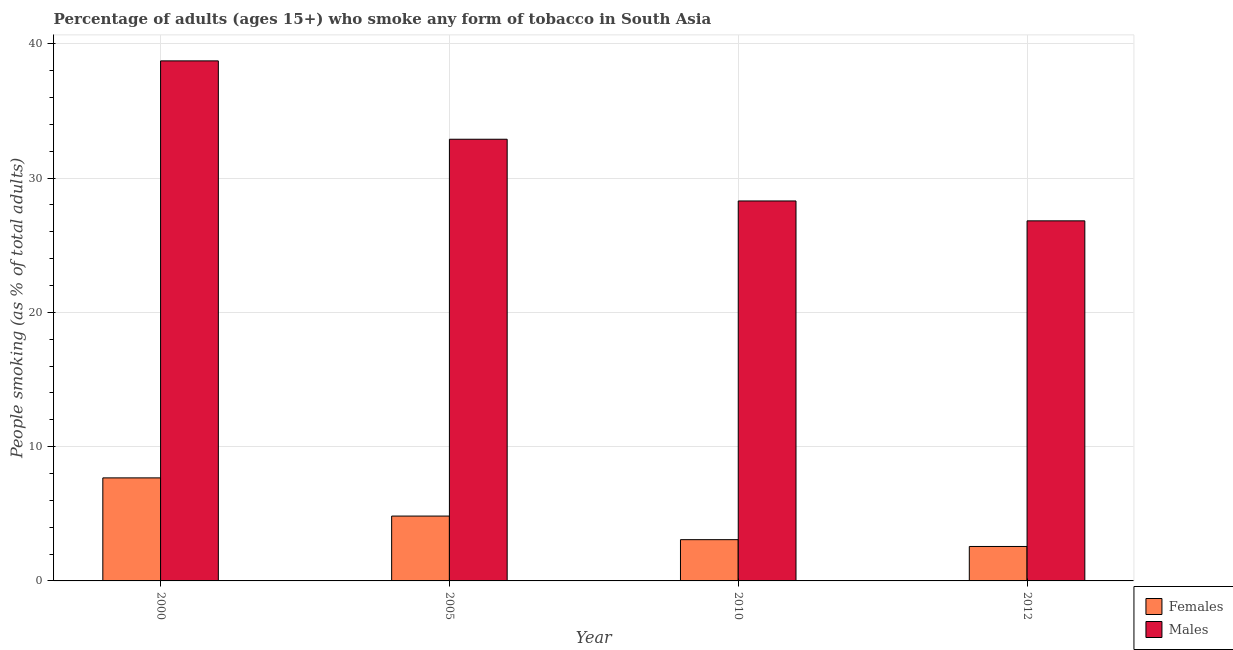How many different coloured bars are there?
Offer a terse response. 2. How many groups of bars are there?
Give a very brief answer. 4. Are the number of bars on each tick of the X-axis equal?
Offer a terse response. Yes. How many bars are there on the 1st tick from the left?
Provide a short and direct response. 2. In how many cases, is the number of bars for a given year not equal to the number of legend labels?
Keep it short and to the point. 0. What is the percentage of females who smoke in 2012?
Make the answer very short. 2.56. Across all years, what is the maximum percentage of females who smoke?
Offer a terse response. 7.67. Across all years, what is the minimum percentage of females who smoke?
Keep it short and to the point. 2.56. In which year was the percentage of females who smoke minimum?
Provide a succinct answer. 2012. What is the total percentage of males who smoke in the graph?
Your answer should be compact. 126.71. What is the difference between the percentage of females who smoke in 2010 and that in 2012?
Ensure brevity in your answer.  0.51. What is the difference between the percentage of males who smoke in 2005 and the percentage of females who smoke in 2010?
Make the answer very short. 4.6. What is the average percentage of males who smoke per year?
Provide a short and direct response. 31.68. What is the ratio of the percentage of females who smoke in 2010 to that in 2012?
Your answer should be very brief. 1.2. What is the difference between the highest and the second highest percentage of females who smoke?
Ensure brevity in your answer.  2.84. What is the difference between the highest and the lowest percentage of females who smoke?
Your answer should be very brief. 5.11. In how many years, is the percentage of males who smoke greater than the average percentage of males who smoke taken over all years?
Make the answer very short. 2. Is the sum of the percentage of females who smoke in 2000 and 2012 greater than the maximum percentage of males who smoke across all years?
Your response must be concise. Yes. What does the 2nd bar from the left in 2005 represents?
Offer a terse response. Males. What does the 2nd bar from the right in 2012 represents?
Give a very brief answer. Females. Are all the bars in the graph horizontal?
Offer a terse response. No. Are the values on the major ticks of Y-axis written in scientific E-notation?
Give a very brief answer. No. Does the graph contain any zero values?
Keep it short and to the point. No. How many legend labels are there?
Give a very brief answer. 2. What is the title of the graph?
Provide a short and direct response. Percentage of adults (ages 15+) who smoke any form of tobacco in South Asia. Does "Nitrous oxide" appear as one of the legend labels in the graph?
Provide a short and direct response. No. What is the label or title of the Y-axis?
Provide a succinct answer. People smoking (as % of total adults). What is the People smoking (as % of total adults) of Females in 2000?
Provide a succinct answer. 7.67. What is the People smoking (as % of total adults) in Males in 2000?
Your answer should be compact. 38.72. What is the People smoking (as % of total adults) of Females in 2005?
Keep it short and to the point. 4.83. What is the People smoking (as % of total adults) of Males in 2005?
Give a very brief answer. 32.89. What is the People smoking (as % of total adults) of Females in 2010?
Ensure brevity in your answer.  3.07. What is the People smoking (as % of total adults) of Males in 2010?
Give a very brief answer. 28.29. What is the People smoking (as % of total adults) of Females in 2012?
Provide a short and direct response. 2.56. What is the People smoking (as % of total adults) of Males in 2012?
Provide a short and direct response. 26.81. Across all years, what is the maximum People smoking (as % of total adults) in Females?
Your answer should be compact. 7.67. Across all years, what is the maximum People smoking (as % of total adults) in Males?
Your answer should be compact. 38.72. Across all years, what is the minimum People smoking (as % of total adults) in Females?
Give a very brief answer. 2.56. Across all years, what is the minimum People smoking (as % of total adults) in Males?
Give a very brief answer. 26.81. What is the total People smoking (as % of total adults) of Females in the graph?
Provide a short and direct response. 18.14. What is the total People smoking (as % of total adults) of Males in the graph?
Your response must be concise. 126.71. What is the difference between the People smoking (as % of total adults) of Females in 2000 and that in 2005?
Provide a succinct answer. 2.84. What is the difference between the People smoking (as % of total adults) of Males in 2000 and that in 2005?
Your answer should be very brief. 5.83. What is the difference between the People smoking (as % of total adults) of Females in 2000 and that in 2010?
Your answer should be very brief. 4.6. What is the difference between the People smoking (as % of total adults) in Males in 2000 and that in 2010?
Offer a very short reply. 10.43. What is the difference between the People smoking (as % of total adults) of Females in 2000 and that in 2012?
Offer a very short reply. 5.11. What is the difference between the People smoking (as % of total adults) in Males in 2000 and that in 2012?
Your response must be concise. 11.91. What is the difference between the People smoking (as % of total adults) of Females in 2005 and that in 2010?
Make the answer very short. 1.76. What is the difference between the People smoking (as % of total adults) of Males in 2005 and that in 2010?
Your response must be concise. 4.6. What is the difference between the People smoking (as % of total adults) of Females in 2005 and that in 2012?
Provide a short and direct response. 2.26. What is the difference between the People smoking (as % of total adults) of Males in 2005 and that in 2012?
Provide a succinct answer. 6.08. What is the difference between the People smoking (as % of total adults) in Females in 2010 and that in 2012?
Offer a very short reply. 0.51. What is the difference between the People smoking (as % of total adults) of Males in 2010 and that in 2012?
Provide a succinct answer. 1.48. What is the difference between the People smoking (as % of total adults) of Females in 2000 and the People smoking (as % of total adults) of Males in 2005?
Provide a short and direct response. -25.21. What is the difference between the People smoking (as % of total adults) in Females in 2000 and the People smoking (as % of total adults) in Males in 2010?
Keep it short and to the point. -20.62. What is the difference between the People smoking (as % of total adults) in Females in 2000 and the People smoking (as % of total adults) in Males in 2012?
Offer a terse response. -19.14. What is the difference between the People smoking (as % of total adults) in Females in 2005 and the People smoking (as % of total adults) in Males in 2010?
Keep it short and to the point. -23.46. What is the difference between the People smoking (as % of total adults) in Females in 2005 and the People smoking (as % of total adults) in Males in 2012?
Give a very brief answer. -21.98. What is the difference between the People smoking (as % of total adults) in Females in 2010 and the People smoking (as % of total adults) in Males in 2012?
Offer a terse response. -23.74. What is the average People smoking (as % of total adults) of Females per year?
Your response must be concise. 4.53. What is the average People smoking (as % of total adults) of Males per year?
Offer a very short reply. 31.68. In the year 2000, what is the difference between the People smoking (as % of total adults) of Females and People smoking (as % of total adults) of Males?
Keep it short and to the point. -31.05. In the year 2005, what is the difference between the People smoking (as % of total adults) in Females and People smoking (as % of total adults) in Males?
Keep it short and to the point. -28.06. In the year 2010, what is the difference between the People smoking (as % of total adults) in Females and People smoking (as % of total adults) in Males?
Offer a very short reply. -25.22. In the year 2012, what is the difference between the People smoking (as % of total adults) of Females and People smoking (as % of total adults) of Males?
Keep it short and to the point. -24.24. What is the ratio of the People smoking (as % of total adults) of Females in 2000 to that in 2005?
Provide a short and direct response. 1.59. What is the ratio of the People smoking (as % of total adults) of Males in 2000 to that in 2005?
Offer a very short reply. 1.18. What is the ratio of the People smoking (as % of total adults) of Females in 2000 to that in 2010?
Provide a succinct answer. 2.5. What is the ratio of the People smoking (as % of total adults) in Males in 2000 to that in 2010?
Ensure brevity in your answer.  1.37. What is the ratio of the People smoking (as % of total adults) in Females in 2000 to that in 2012?
Give a very brief answer. 2.99. What is the ratio of the People smoking (as % of total adults) in Males in 2000 to that in 2012?
Keep it short and to the point. 1.44. What is the ratio of the People smoking (as % of total adults) of Females in 2005 to that in 2010?
Your answer should be very brief. 1.57. What is the ratio of the People smoking (as % of total adults) of Males in 2005 to that in 2010?
Keep it short and to the point. 1.16. What is the ratio of the People smoking (as % of total adults) of Females in 2005 to that in 2012?
Provide a succinct answer. 1.88. What is the ratio of the People smoking (as % of total adults) in Males in 2005 to that in 2012?
Ensure brevity in your answer.  1.23. What is the ratio of the People smoking (as % of total adults) in Females in 2010 to that in 2012?
Make the answer very short. 1.2. What is the ratio of the People smoking (as % of total adults) in Males in 2010 to that in 2012?
Offer a terse response. 1.06. What is the difference between the highest and the second highest People smoking (as % of total adults) in Females?
Offer a terse response. 2.84. What is the difference between the highest and the second highest People smoking (as % of total adults) of Males?
Provide a succinct answer. 5.83. What is the difference between the highest and the lowest People smoking (as % of total adults) of Females?
Make the answer very short. 5.11. What is the difference between the highest and the lowest People smoking (as % of total adults) of Males?
Keep it short and to the point. 11.91. 